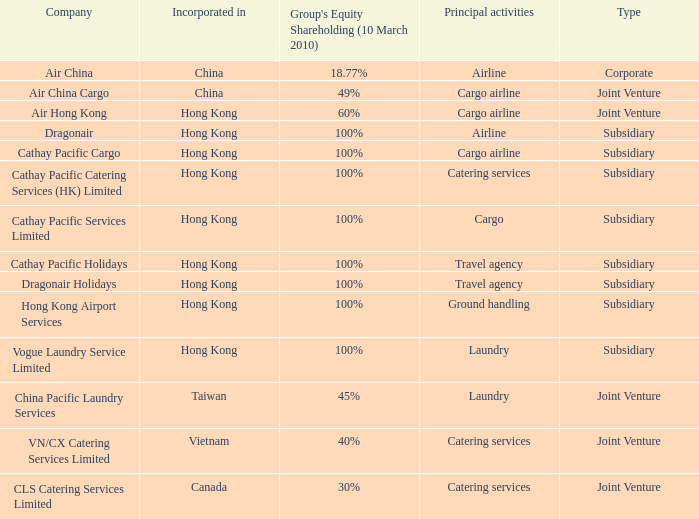Which  company's type is joint venture, and has principle activities listed as Cargo Airline and an incorporation of China? Air China Cargo. 